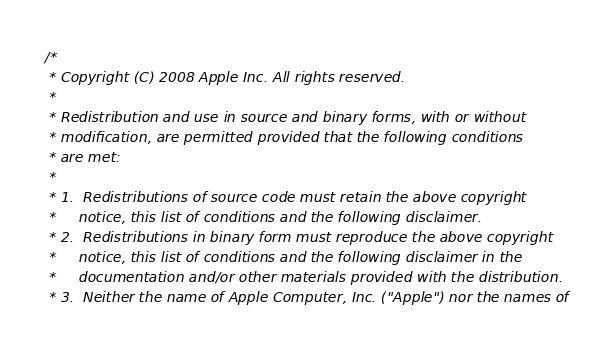<code> <loc_0><loc_0><loc_500><loc_500><_C_>/*
 * Copyright (C) 2008 Apple Inc. All rights reserved.
 *
 * Redistribution and use in source and binary forms, with or without
 * modification, are permitted provided that the following conditions
 * are met:
 *
 * 1.  Redistributions of source code must retain the above copyright
 *     notice, this list of conditions and the following disclaimer.
 * 2.  Redistributions in binary form must reproduce the above copyright
 *     notice, this list of conditions and the following disclaimer in the
 *     documentation and/or other materials provided with the distribution.
 * 3.  Neither the name of Apple Computer, Inc. ("Apple") nor the names of</code> 